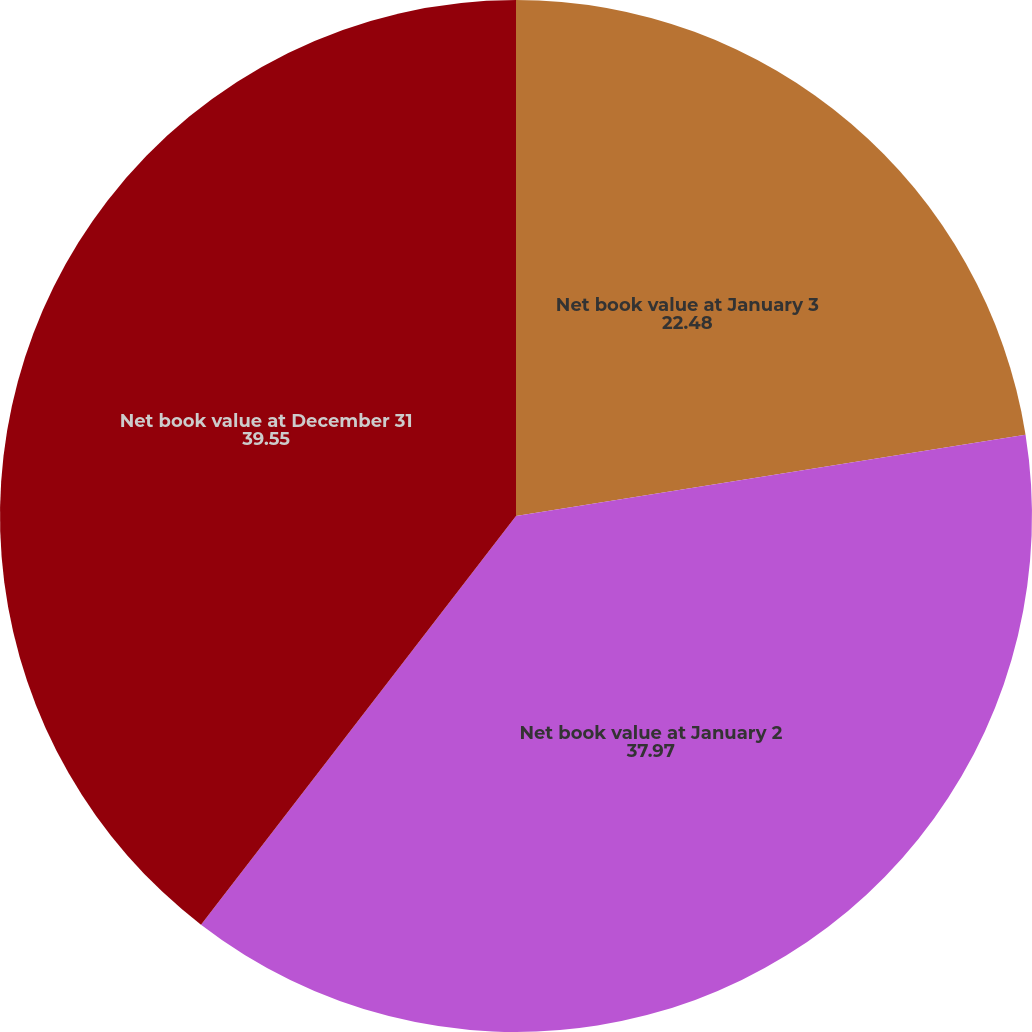Convert chart to OTSL. <chart><loc_0><loc_0><loc_500><loc_500><pie_chart><fcel>Net book value at January 3<fcel>Net book value at January 2<fcel>Net book value at December 31<nl><fcel>22.48%<fcel>37.97%<fcel>39.55%<nl></chart> 